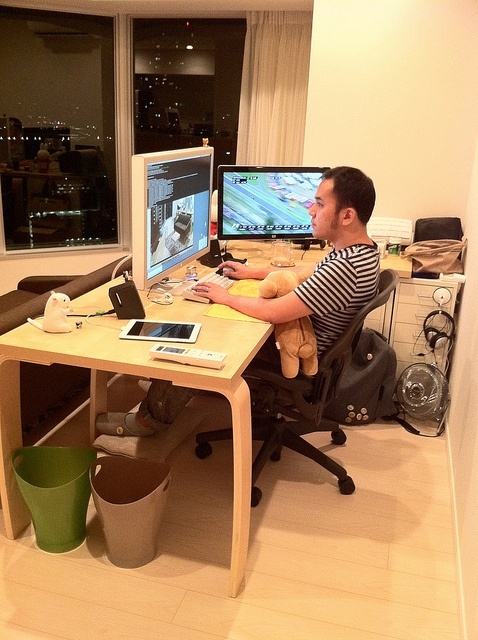Describe the objects in this image and their specific colors. I can see dining table in brown, khaki, orange, and black tones, people in brown, black, maroon, salmon, and tan tones, chair in brown, black, maroon, gray, and tan tones, tv in brown, tan, lightgray, darkgray, and gray tones, and tv in brown, lightblue, and black tones in this image. 